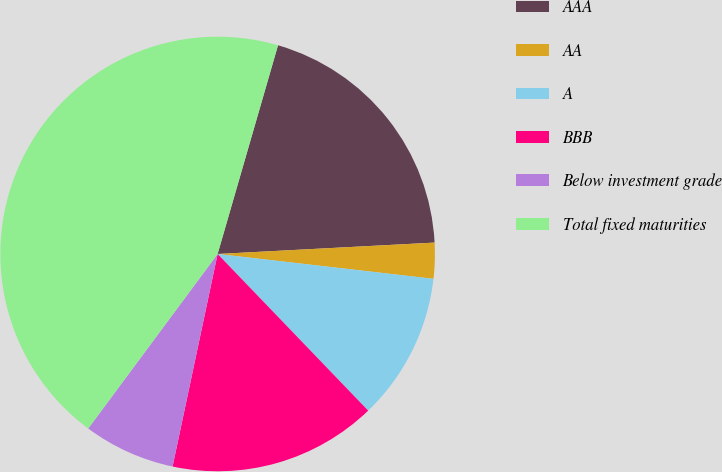Convert chart. <chart><loc_0><loc_0><loc_500><loc_500><pie_chart><fcel>AAA<fcel>AA<fcel>A<fcel>BBB<fcel>Below investment grade<fcel>Total fixed maturities<nl><fcel>19.68%<fcel>2.66%<fcel>10.99%<fcel>15.51%<fcel>6.83%<fcel>44.33%<nl></chart> 